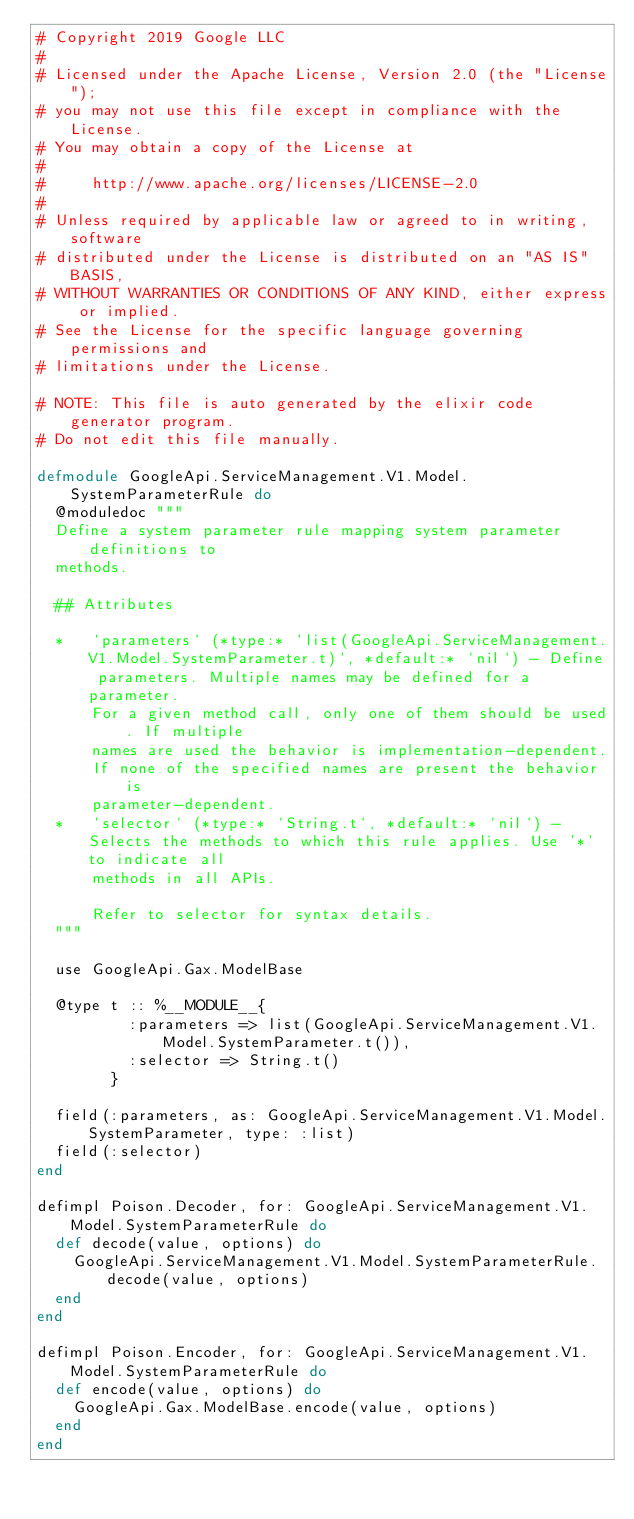Convert code to text. <code><loc_0><loc_0><loc_500><loc_500><_Elixir_># Copyright 2019 Google LLC
#
# Licensed under the Apache License, Version 2.0 (the "License");
# you may not use this file except in compliance with the License.
# You may obtain a copy of the License at
#
#     http://www.apache.org/licenses/LICENSE-2.0
#
# Unless required by applicable law or agreed to in writing, software
# distributed under the License is distributed on an "AS IS" BASIS,
# WITHOUT WARRANTIES OR CONDITIONS OF ANY KIND, either express or implied.
# See the License for the specific language governing permissions and
# limitations under the License.

# NOTE: This file is auto generated by the elixir code generator program.
# Do not edit this file manually.

defmodule GoogleApi.ServiceManagement.V1.Model.SystemParameterRule do
  @moduledoc """
  Define a system parameter rule mapping system parameter definitions to
  methods.

  ## Attributes

  *   `parameters` (*type:* `list(GoogleApi.ServiceManagement.V1.Model.SystemParameter.t)`, *default:* `nil`) - Define parameters. Multiple names may be defined for a parameter.
      For a given method call, only one of them should be used. If multiple
      names are used the behavior is implementation-dependent.
      If none of the specified names are present the behavior is
      parameter-dependent.
  *   `selector` (*type:* `String.t`, *default:* `nil`) - Selects the methods to which this rule applies. Use '*' to indicate all
      methods in all APIs.

      Refer to selector for syntax details.
  """

  use GoogleApi.Gax.ModelBase

  @type t :: %__MODULE__{
          :parameters => list(GoogleApi.ServiceManagement.V1.Model.SystemParameter.t()),
          :selector => String.t()
        }

  field(:parameters, as: GoogleApi.ServiceManagement.V1.Model.SystemParameter, type: :list)
  field(:selector)
end

defimpl Poison.Decoder, for: GoogleApi.ServiceManagement.V1.Model.SystemParameterRule do
  def decode(value, options) do
    GoogleApi.ServiceManagement.V1.Model.SystemParameterRule.decode(value, options)
  end
end

defimpl Poison.Encoder, for: GoogleApi.ServiceManagement.V1.Model.SystemParameterRule do
  def encode(value, options) do
    GoogleApi.Gax.ModelBase.encode(value, options)
  end
end
</code> 